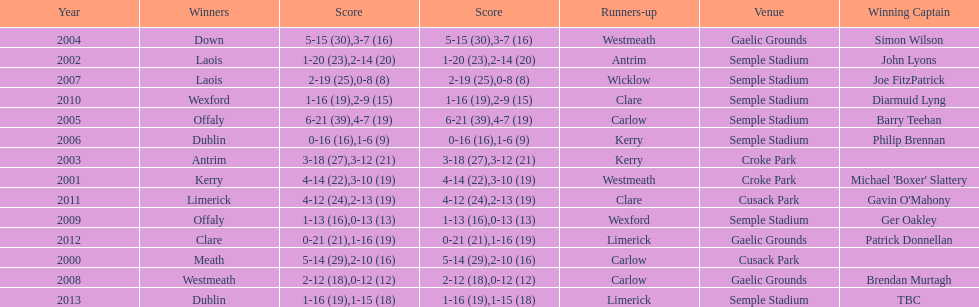Which team was the first to win with a team captain? Kerry. Help me parse the entirety of this table. {'header': ['Year', 'Winners', 'Score', 'Score', 'Runners-up', 'Venue', 'Winning Captain'], 'rows': [['2004', 'Down', '5-15 (30)', '3-7 (16)', 'Westmeath', 'Gaelic Grounds', 'Simon Wilson'], ['2002', 'Laois', '1-20 (23)', '2-14 (20)', 'Antrim', 'Semple Stadium', 'John Lyons'], ['2007', 'Laois', '2-19 (25)', '0-8 (8)', 'Wicklow', 'Semple Stadium', 'Joe FitzPatrick'], ['2010', 'Wexford', '1-16 (19)', '2-9 (15)', 'Clare', 'Semple Stadium', 'Diarmuid Lyng'], ['2005', 'Offaly', '6-21 (39)', '4-7 (19)', 'Carlow', 'Semple Stadium', 'Barry Teehan'], ['2006', 'Dublin', '0-16 (16)', '1-6 (9)', 'Kerry', 'Semple Stadium', 'Philip Brennan'], ['2003', 'Antrim', '3-18 (27)', '3-12 (21)', 'Kerry', 'Croke Park', ''], ['2001', 'Kerry', '4-14 (22)', '3-10 (19)', 'Westmeath', 'Croke Park', "Michael 'Boxer' Slattery"], ['2011', 'Limerick', '4-12 (24)', '2-13 (19)', 'Clare', 'Cusack Park', "Gavin O'Mahony"], ['2009', 'Offaly', '1-13 (16)', '0-13 (13)', 'Wexford', 'Semple Stadium', 'Ger Oakley'], ['2012', 'Clare', '0-21 (21)', '1-16 (19)', 'Limerick', 'Gaelic Grounds', 'Patrick Donnellan'], ['2000', 'Meath', '5-14 (29)', '2-10 (16)', 'Carlow', 'Cusack Park', ''], ['2008', 'Westmeath', '2-12 (18)', '0-12 (12)', 'Carlow', 'Gaelic Grounds', 'Brendan Murtagh'], ['2013', 'Dublin', '1-16 (19)', '1-15 (18)', 'Limerick', 'Semple Stadium', 'TBC']]} 